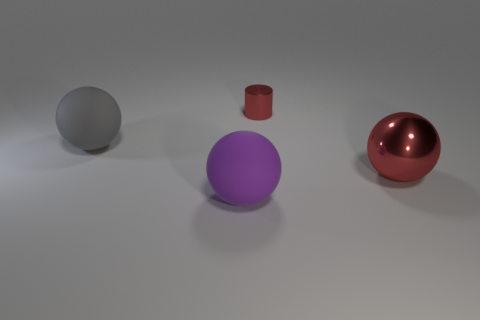Is there anything else that is the same size as the cylinder?
Your answer should be very brief. No. There is a large matte thing that is behind the purple matte thing; how many large red balls are to the right of it?
Your answer should be compact. 1. Do the large metal object and the big rubber object right of the large gray matte object have the same color?
Offer a terse response. No. The other matte ball that is the same size as the gray matte ball is what color?
Your response must be concise. Purple. Are there any other things of the same shape as the purple rubber thing?
Your answer should be compact. Yes. Are there fewer gray matte objects than rubber objects?
Make the answer very short. Yes. There is a ball that is on the right side of the cylinder; what color is it?
Give a very brief answer. Red. The large rubber thing that is in front of the big thing to the right of the purple matte object is what shape?
Offer a very short reply. Sphere. Are the small red object and the red object that is in front of the large gray rubber object made of the same material?
Provide a short and direct response. Yes. There is a large thing that is the same color as the tiny object; what shape is it?
Keep it short and to the point. Sphere. 